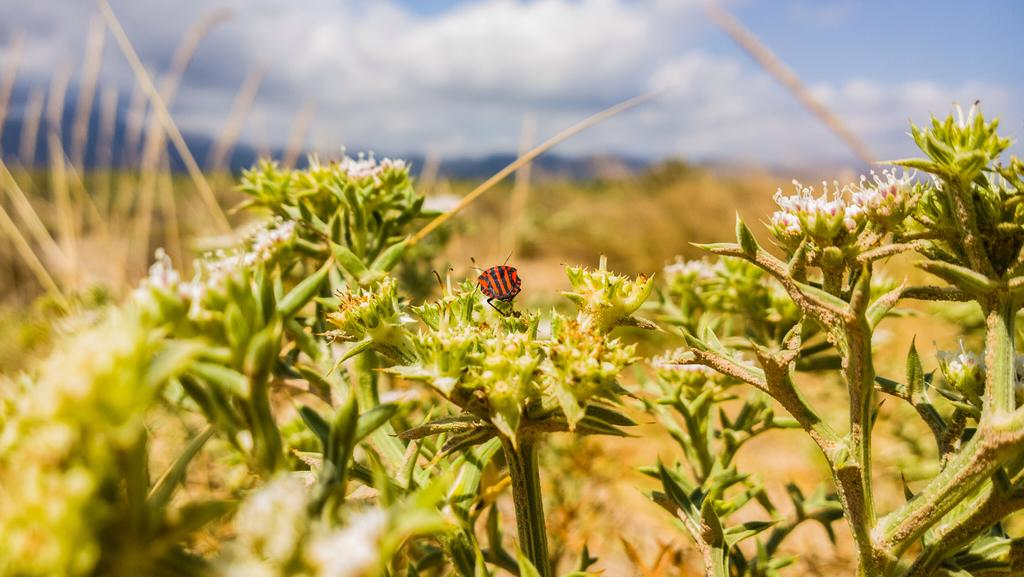What type of plants can be seen in the image? There are plants with flowers in the image. Can you describe any specific activity involving the plants? Yes, there is an insect on a flower in the image. What can be observed about the background of the image? The background of the image is blurred. What type of apparatus is used to wash the insect in the image? There is no apparatus used to wash the insect in the image, as it is a still photograph and not a video or live scene. 